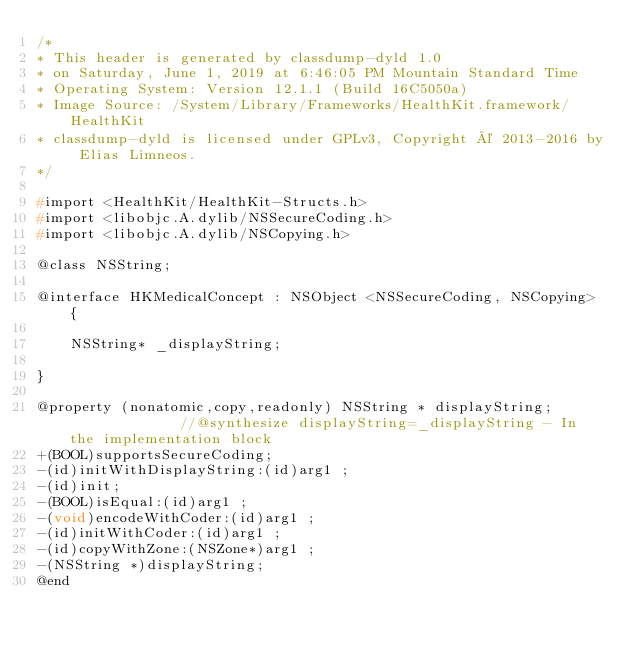Convert code to text. <code><loc_0><loc_0><loc_500><loc_500><_C_>/*
* This header is generated by classdump-dyld 1.0
* on Saturday, June 1, 2019 at 6:46:05 PM Mountain Standard Time
* Operating System: Version 12.1.1 (Build 16C5050a)
* Image Source: /System/Library/Frameworks/HealthKit.framework/HealthKit
* classdump-dyld is licensed under GPLv3, Copyright © 2013-2016 by Elias Limneos.
*/

#import <HealthKit/HealthKit-Structs.h>
#import <libobjc.A.dylib/NSSecureCoding.h>
#import <libobjc.A.dylib/NSCopying.h>

@class NSString;

@interface HKMedicalConcept : NSObject <NSSecureCoding, NSCopying> {

	NSString* _displayString;

}

@property (nonatomic,copy,readonly) NSString * displayString;              //@synthesize displayString=_displayString - In the implementation block
+(BOOL)supportsSecureCoding;
-(id)initWithDisplayString:(id)arg1 ;
-(id)init;
-(BOOL)isEqual:(id)arg1 ;
-(void)encodeWithCoder:(id)arg1 ;
-(id)initWithCoder:(id)arg1 ;
-(id)copyWithZone:(NSZone*)arg1 ;
-(NSString *)displayString;
@end

</code> 